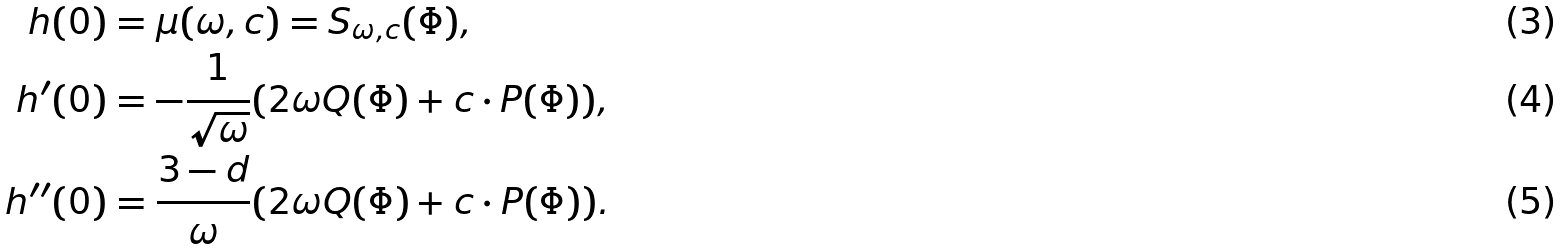Convert formula to latex. <formula><loc_0><loc_0><loc_500><loc_500>h ( 0 ) & = \mu ( \omega , c ) = S _ { \omega , c } ( \Phi ) , \\ h ^ { \prime } ( 0 ) & = - \frac { 1 } { \sqrt { \omega } } ( 2 \omega Q ( \Phi ) + c \cdot P ( \Phi ) ) , \\ h ^ { \prime \prime } ( 0 ) & = \frac { 3 - d } { \omega } ( 2 \omega Q ( \Phi ) + c \cdot P ( \Phi ) ) .</formula> 